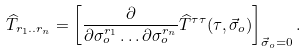<formula> <loc_0><loc_0><loc_500><loc_500>\widehat { T } _ { r _ { 1 } . . r _ { n } } = \left [ \frac { \partial } { \partial \sigma _ { o } ^ { r _ { 1 } } \dots \partial \sigma _ { o } ^ { r _ { n } } } \widehat { T } ^ { \tau \tau } ( \tau , \vec { \sigma } _ { o } ) \right ] _ { \vec { \sigma } _ { o } = 0 } .</formula> 